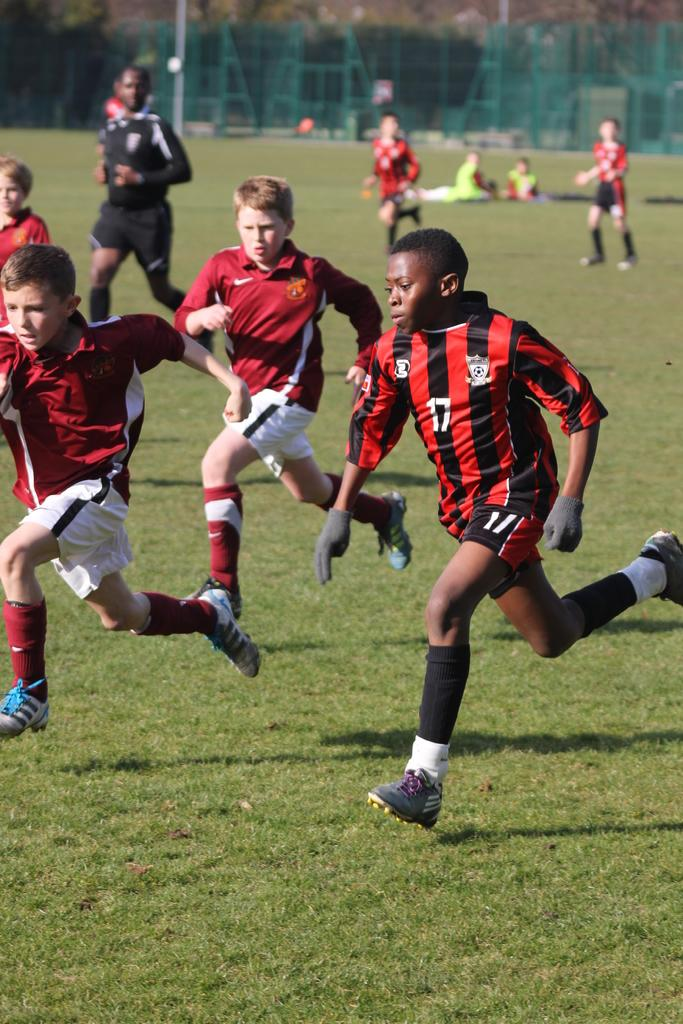Provide a one-sentence caption for the provided image. Youth soccer player in orange and black with 17 on the shirt. 